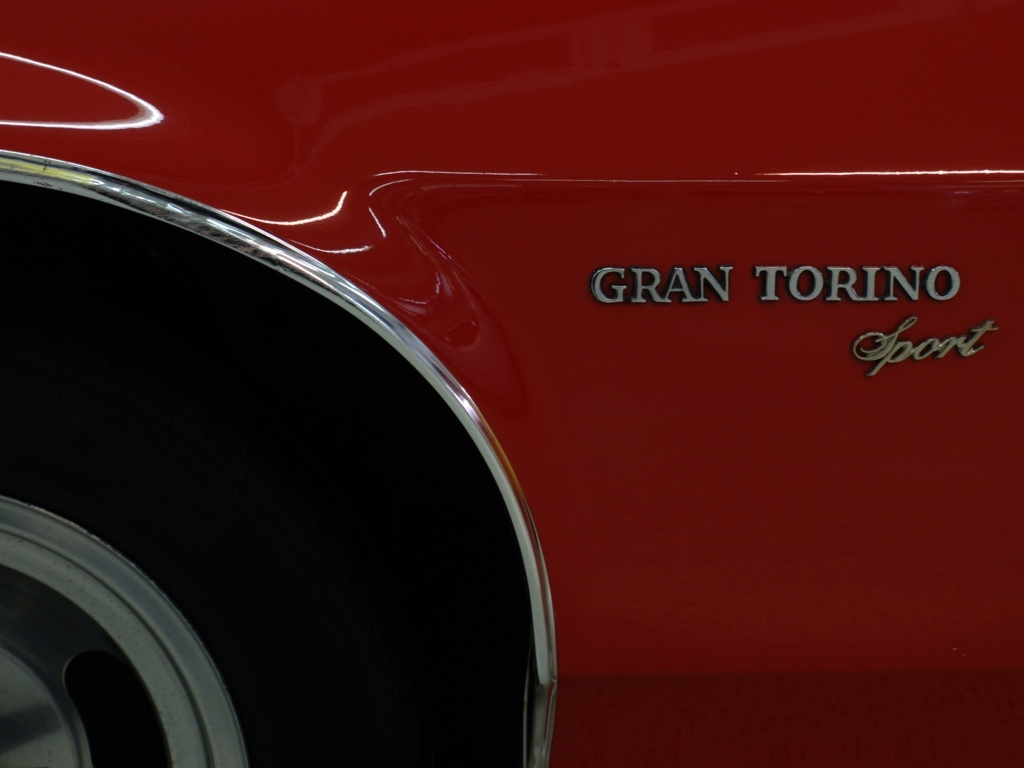What era does the car's design suggest? The styling cues visible in the image, such as the sleek body lines, the use of chrome trim, and the type of wheel seen here, suggest that this car is from the 1970s. This was a time when muscle cars with distinctive, bold styles were prevalent, especially in the American automotive industry. 